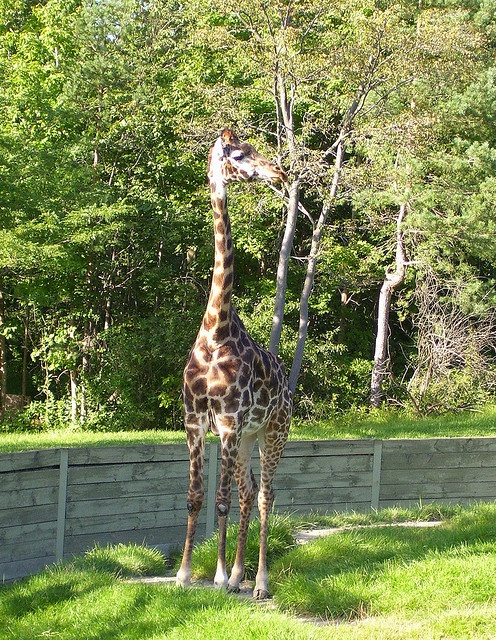Describe the objects in this image and their specific colors. I can see a giraffe in khaki, gray, black, ivory, and darkgreen tones in this image. 